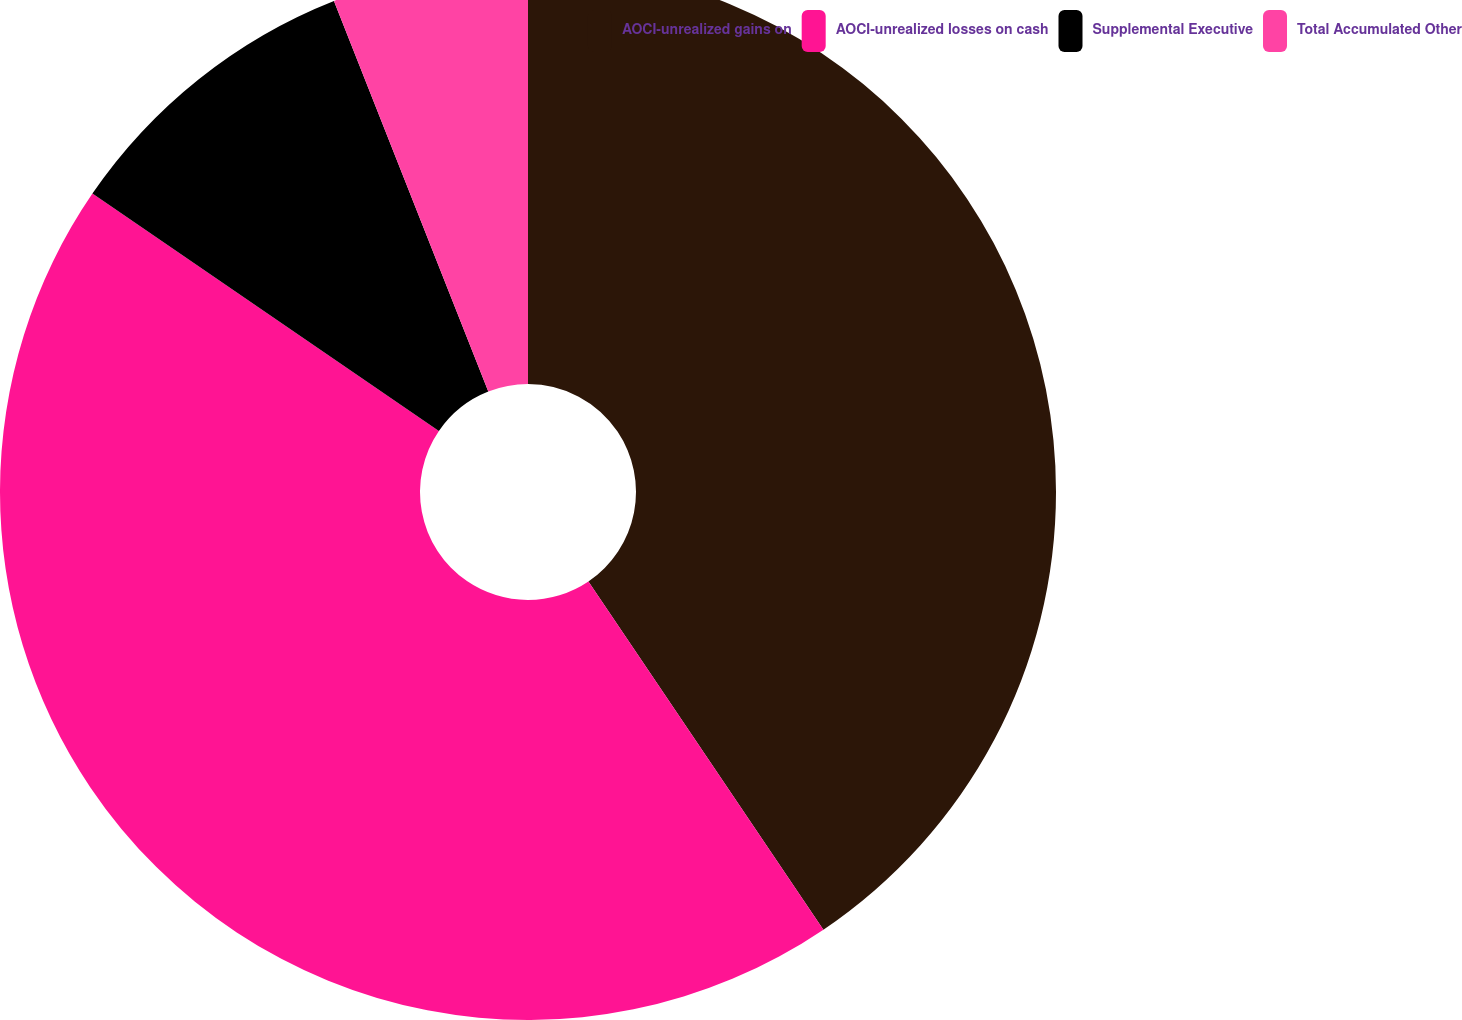Convert chart to OTSL. <chart><loc_0><loc_0><loc_500><loc_500><pie_chart><fcel>AOCI-unrealized gains on<fcel>AOCI-unrealized losses on cash<fcel>Supplemental Executive<fcel>Total Accumulated Other<nl><fcel>40.55%<fcel>44.01%<fcel>9.45%<fcel>5.99%<nl></chart> 